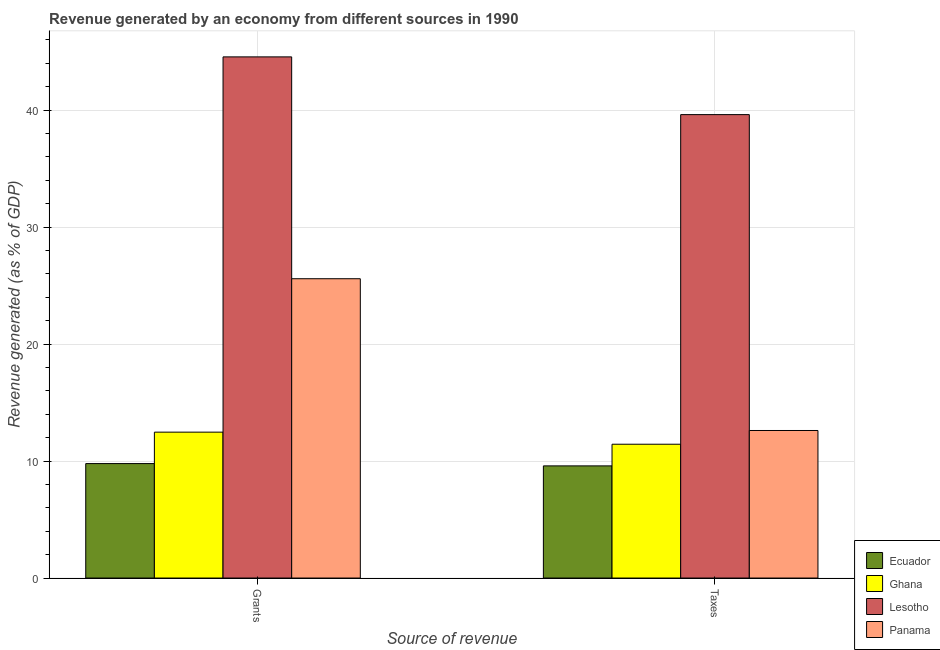Are the number of bars per tick equal to the number of legend labels?
Provide a short and direct response. Yes. How many bars are there on the 1st tick from the right?
Ensure brevity in your answer.  4. What is the label of the 2nd group of bars from the left?
Provide a succinct answer. Taxes. What is the revenue generated by grants in Panama?
Offer a terse response. 25.58. Across all countries, what is the maximum revenue generated by taxes?
Ensure brevity in your answer.  39.6. Across all countries, what is the minimum revenue generated by taxes?
Provide a succinct answer. 9.59. In which country was the revenue generated by grants maximum?
Offer a very short reply. Lesotho. In which country was the revenue generated by taxes minimum?
Your response must be concise. Ecuador. What is the total revenue generated by taxes in the graph?
Ensure brevity in your answer.  73.24. What is the difference between the revenue generated by grants in Lesotho and that in Panama?
Your answer should be very brief. 18.96. What is the difference between the revenue generated by taxes in Ghana and the revenue generated by grants in Panama?
Your answer should be very brief. -14.14. What is the average revenue generated by grants per country?
Provide a succinct answer. 23.09. What is the difference between the revenue generated by taxes and revenue generated by grants in Ecuador?
Your answer should be very brief. -0.2. What is the ratio of the revenue generated by taxes in Panama to that in Ecuador?
Provide a succinct answer. 1.32. Is the revenue generated by grants in Panama less than that in Ecuador?
Provide a short and direct response. No. In how many countries, is the revenue generated by grants greater than the average revenue generated by grants taken over all countries?
Offer a terse response. 2. What does the 2nd bar from the left in Grants represents?
Make the answer very short. Ghana. What does the 4th bar from the right in Taxes represents?
Your response must be concise. Ecuador. How many bars are there?
Make the answer very short. 8. How many countries are there in the graph?
Your answer should be compact. 4. What is the difference between two consecutive major ticks on the Y-axis?
Provide a succinct answer. 10. Does the graph contain any zero values?
Ensure brevity in your answer.  No. Does the graph contain grids?
Ensure brevity in your answer.  Yes. What is the title of the graph?
Your answer should be compact. Revenue generated by an economy from different sources in 1990. Does "Timor-Leste" appear as one of the legend labels in the graph?
Your answer should be very brief. No. What is the label or title of the X-axis?
Keep it short and to the point. Source of revenue. What is the label or title of the Y-axis?
Keep it short and to the point. Revenue generated (as % of GDP). What is the Revenue generated (as % of GDP) of Ecuador in Grants?
Offer a very short reply. 9.78. What is the Revenue generated (as % of GDP) of Ghana in Grants?
Your answer should be compact. 12.47. What is the Revenue generated (as % of GDP) in Lesotho in Grants?
Make the answer very short. 44.54. What is the Revenue generated (as % of GDP) in Panama in Grants?
Give a very brief answer. 25.58. What is the Revenue generated (as % of GDP) of Ecuador in Taxes?
Ensure brevity in your answer.  9.59. What is the Revenue generated (as % of GDP) in Ghana in Taxes?
Ensure brevity in your answer.  11.44. What is the Revenue generated (as % of GDP) in Lesotho in Taxes?
Offer a very short reply. 39.6. What is the Revenue generated (as % of GDP) in Panama in Taxes?
Keep it short and to the point. 12.61. Across all Source of revenue, what is the maximum Revenue generated (as % of GDP) in Ecuador?
Ensure brevity in your answer.  9.78. Across all Source of revenue, what is the maximum Revenue generated (as % of GDP) in Ghana?
Offer a terse response. 12.47. Across all Source of revenue, what is the maximum Revenue generated (as % of GDP) of Lesotho?
Your answer should be very brief. 44.54. Across all Source of revenue, what is the maximum Revenue generated (as % of GDP) in Panama?
Provide a short and direct response. 25.58. Across all Source of revenue, what is the minimum Revenue generated (as % of GDP) in Ecuador?
Your answer should be compact. 9.59. Across all Source of revenue, what is the minimum Revenue generated (as % of GDP) in Ghana?
Make the answer very short. 11.44. Across all Source of revenue, what is the minimum Revenue generated (as % of GDP) in Lesotho?
Your response must be concise. 39.6. Across all Source of revenue, what is the minimum Revenue generated (as % of GDP) of Panama?
Provide a succinct answer. 12.61. What is the total Revenue generated (as % of GDP) in Ecuador in the graph?
Your response must be concise. 19.37. What is the total Revenue generated (as % of GDP) of Ghana in the graph?
Provide a short and direct response. 23.91. What is the total Revenue generated (as % of GDP) of Lesotho in the graph?
Give a very brief answer. 84.14. What is the total Revenue generated (as % of GDP) of Panama in the graph?
Your response must be concise. 38.19. What is the difference between the Revenue generated (as % of GDP) of Ecuador in Grants and that in Taxes?
Ensure brevity in your answer.  0.2. What is the difference between the Revenue generated (as % of GDP) of Ghana in Grants and that in Taxes?
Offer a terse response. 1.03. What is the difference between the Revenue generated (as % of GDP) in Lesotho in Grants and that in Taxes?
Keep it short and to the point. 4.93. What is the difference between the Revenue generated (as % of GDP) of Panama in Grants and that in Taxes?
Make the answer very short. 12.97. What is the difference between the Revenue generated (as % of GDP) in Ecuador in Grants and the Revenue generated (as % of GDP) in Ghana in Taxes?
Ensure brevity in your answer.  -1.65. What is the difference between the Revenue generated (as % of GDP) in Ecuador in Grants and the Revenue generated (as % of GDP) in Lesotho in Taxes?
Make the answer very short. -29.82. What is the difference between the Revenue generated (as % of GDP) in Ecuador in Grants and the Revenue generated (as % of GDP) in Panama in Taxes?
Offer a terse response. -2.83. What is the difference between the Revenue generated (as % of GDP) in Ghana in Grants and the Revenue generated (as % of GDP) in Lesotho in Taxes?
Your answer should be compact. -27.14. What is the difference between the Revenue generated (as % of GDP) in Ghana in Grants and the Revenue generated (as % of GDP) in Panama in Taxes?
Your answer should be compact. -0.14. What is the difference between the Revenue generated (as % of GDP) of Lesotho in Grants and the Revenue generated (as % of GDP) of Panama in Taxes?
Your answer should be very brief. 31.93. What is the average Revenue generated (as % of GDP) in Ecuador per Source of revenue?
Provide a succinct answer. 9.68. What is the average Revenue generated (as % of GDP) of Ghana per Source of revenue?
Your answer should be compact. 11.95. What is the average Revenue generated (as % of GDP) of Lesotho per Source of revenue?
Provide a succinct answer. 42.07. What is the average Revenue generated (as % of GDP) of Panama per Source of revenue?
Make the answer very short. 19.09. What is the difference between the Revenue generated (as % of GDP) in Ecuador and Revenue generated (as % of GDP) in Ghana in Grants?
Offer a terse response. -2.69. What is the difference between the Revenue generated (as % of GDP) in Ecuador and Revenue generated (as % of GDP) in Lesotho in Grants?
Provide a succinct answer. -34.76. What is the difference between the Revenue generated (as % of GDP) in Ecuador and Revenue generated (as % of GDP) in Panama in Grants?
Provide a short and direct response. -15.8. What is the difference between the Revenue generated (as % of GDP) in Ghana and Revenue generated (as % of GDP) in Lesotho in Grants?
Give a very brief answer. -32.07. What is the difference between the Revenue generated (as % of GDP) of Ghana and Revenue generated (as % of GDP) of Panama in Grants?
Provide a succinct answer. -13.11. What is the difference between the Revenue generated (as % of GDP) in Lesotho and Revenue generated (as % of GDP) in Panama in Grants?
Keep it short and to the point. 18.96. What is the difference between the Revenue generated (as % of GDP) in Ecuador and Revenue generated (as % of GDP) in Ghana in Taxes?
Your response must be concise. -1.85. What is the difference between the Revenue generated (as % of GDP) in Ecuador and Revenue generated (as % of GDP) in Lesotho in Taxes?
Your answer should be very brief. -30.02. What is the difference between the Revenue generated (as % of GDP) in Ecuador and Revenue generated (as % of GDP) in Panama in Taxes?
Offer a terse response. -3.02. What is the difference between the Revenue generated (as % of GDP) in Ghana and Revenue generated (as % of GDP) in Lesotho in Taxes?
Provide a short and direct response. -28.17. What is the difference between the Revenue generated (as % of GDP) in Ghana and Revenue generated (as % of GDP) in Panama in Taxes?
Your response must be concise. -1.17. What is the difference between the Revenue generated (as % of GDP) in Lesotho and Revenue generated (as % of GDP) in Panama in Taxes?
Your answer should be very brief. 26.99. What is the ratio of the Revenue generated (as % of GDP) in Ecuador in Grants to that in Taxes?
Offer a terse response. 1.02. What is the ratio of the Revenue generated (as % of GDP) in Ghana in Grants to that in Taxes?
Your response must be concise. 1.09. What is the ratio of the Revenue generated (as % of GDP) of Lesotho in Grants to that in Taxes?
Give a very brief answer. 1.12. What is the ratio of the Revenue generated (as % of GDP) in Panama in Grants to that in Taxes?
Your response must be concise. 2.03. What is the difference between the highest and the second highest Revenue generated (as % of GDP) of Ecuador?
Your response must be concise. 0.2. What is the difference between the highest and the second highest Revenue generated (as % of GDP) of Ghana?
Your answer should be compact. 1.03. What is the difference between the highest and the second highest Revenue generated (as % of GDP) in Lesotho?
Your answer should be compact. 4.93. What is the difference between the highest and the second highest Revenue generated (as % of GDP) in Panama?
Keep it short and to the point. 12.97. What is the difference between the highest and the lowest Revenue generated (as % of GDP) in Ecuador?
Your response must be concise. 0.2. What is the difference between the highest and the lowest Revenue generated (as % of GDP) in Ghana?
Ensure brevity in your answer.  1.03. What is the difference between the highest and the lowest Revenue generated (as % of GDP) in Lesotho?
Provide a short and direct response. 4.93. What is the difference between the highest and the lowest Revenue generated (as % of GDP) of Panama?
Your answer should be very brief. 12.97. 